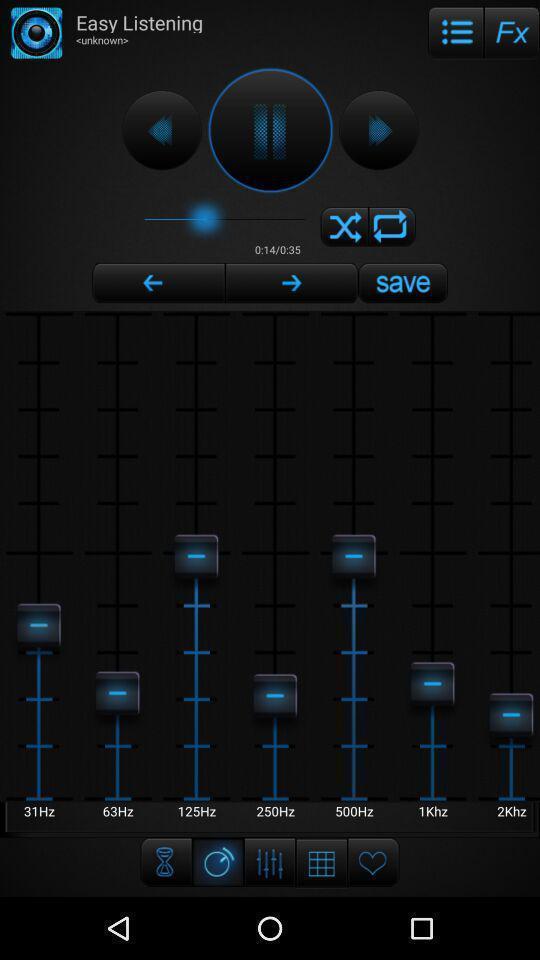Tell me what you see in this picture. Page showing options of audio. 